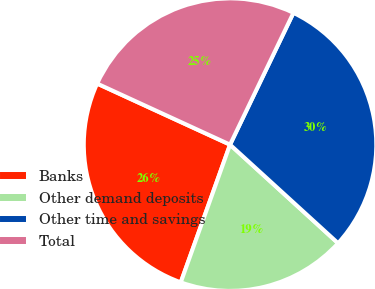Convert chart to OTSL. <chart><loc_0><loc_0><loc_500><loc_500><pie_chart><fcel>Banks<fcel>Other demand deposits<fcel>Other time and savings<fcel>Total<nl><fcel>26.39%<fcel>18.7%<fcel>29.64%<fcel>25.28%<nl></chart> 